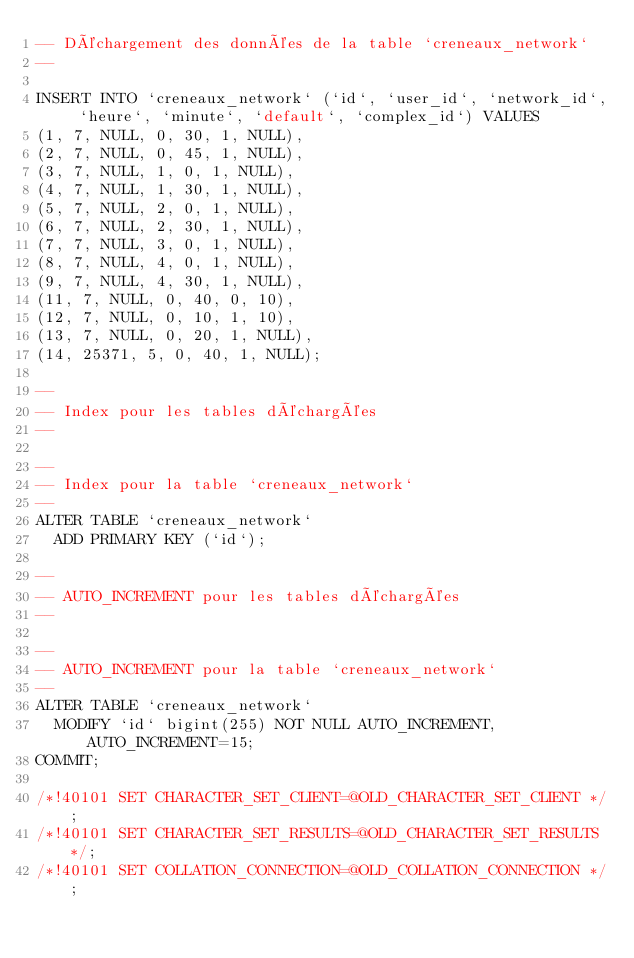Convert code to text. <code><loc_0><loc_0><loc_500><loc_500><_SQL_>-- Déchargement des données de la table `creneaux_network`
--

INSERT INTO `creneaux_network` (`id`, `user_id`, `network_id`, `heure`, `minute`, `default`, `complex_id`) VALUES
(1, 7, NULL, 0, 30, 1, NULL),
(2, 7, NULL, 0, 45, 1, NULL),
(3, 7, NULL, 1, 0, 1, NULL),
(4, 7, NULL, 1, 30, 1, NULL),
(5, 7, NULL, 2, 0, 1, NULL),
(6, 7, NULL, 2, 30, 1, NULL),
(7, 7, NULL, 3, 0, 1, NULL),
(8, 7, NULL, 4, 0, 1, NULL),
(9, 7, NULL, 4, 30, 1, NULL),
(11, 7, NULL, 0, 40, 0, 10),
(12, 7, NULL, 0, 10, 1, 10),
(13, 7, NULL, 0, 20, 1, NULL),
(14, 25371, 5, 0, 40, 1, NULL);

--
-- Index pour les tables déchargées
--

--
-- Index pour la table `creneaux_network`
--
ALTER TABLE `creneaux_network`
  ADD PRIMARY KEY (`id`);

--
-- AUTO_INCREMENT pour les tables déchargées
--

--
-- AUTO_INCREMENT pour la table `creneaux_network`
--
ALTER TABLE `creneaux_network`
  MODIFY `id` bigint(255) NOT NULL AUTO_INCREMENT, AUTO_INCREMENT=15;
COMMIT;

/*!40101 SET CHARACTER_SET_CLIENT=@OLD_CHARACTER_SET_CLIENT */;
/*!40101 SET CHARACTER_SET_RESULTS=@OLD_CHARACTER_SET_RESULTS */;
/*!40101 SET COLLATION_CONNECTION=@OLD_COLLATION_CONNECTION */;
</code> 